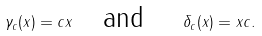<formula> <loc_0><loc_0><loc_500><loc_500>\gamma _ { c } ( x ) = c x \quad \text {and \quad } \delta _ { c } ( x ) = x c .</formula> 